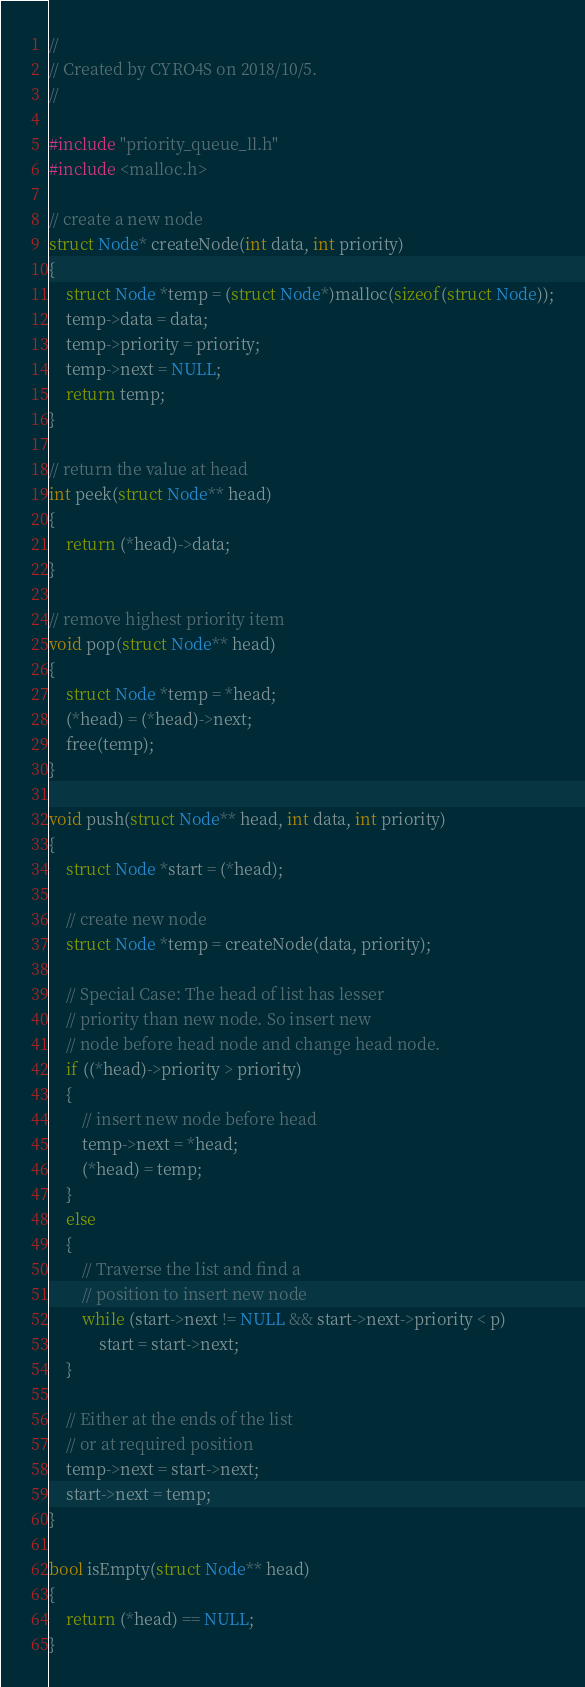Convert code to text. <code><loc_0><loc_0><loc_500><loc_500><_C_>//
// Created by CYRO4S on 2018/10/5.
//

#include "priority_queue_ll.h"
#include <malloc.h>

// create a new node
struct Node* createNode(int data, int priority)
{
    struct Node *temp = (struct Node*)malloc(sizeof(struct Node));
    temp->data = data;
    temp->priority = priority;
    temp->next = NULL;
    return temp;
}

// return the value at head
int peek(struct Node** head)
{
    return (*head)->data;
}

// remove highest priority item
void pop(struct Node** head)
{
    struct Node *temp = *head;
    (*head) = (*head)->next;
    free(temp);
}

void push(struct Node** head, int data, int priority)
{
    struct Node *start = (*head);

    // create new node
    struct Node *temp = createNode(data, priority);

    // Special Case: The head of list has lesser
    // priority than new node. So insert new
    // node before head node and change head node.
    if ((*head)->priority > priority)
    {
        // insert new node before head
        temp->next = *head;
        (*head) = temp;
    }
    else
    {
        // Traverse the list and find a
        // position to insert new node
        while (start->next != NULL && start->next->priority < p)
            start = start->next;
    }

    // Either at the ends of the list
    // or at required position
    temp->next = start->next;
    start->next = temp;
}

bool isEmpty(struct Node** head)
{
    return (*head) == NULL;
}</code> 